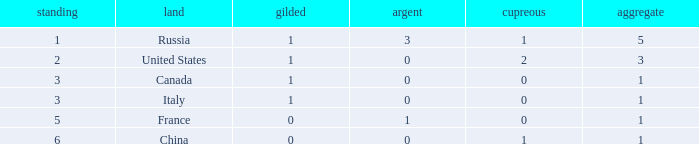Name the total number of ranks when total is less than 1 0.0. 